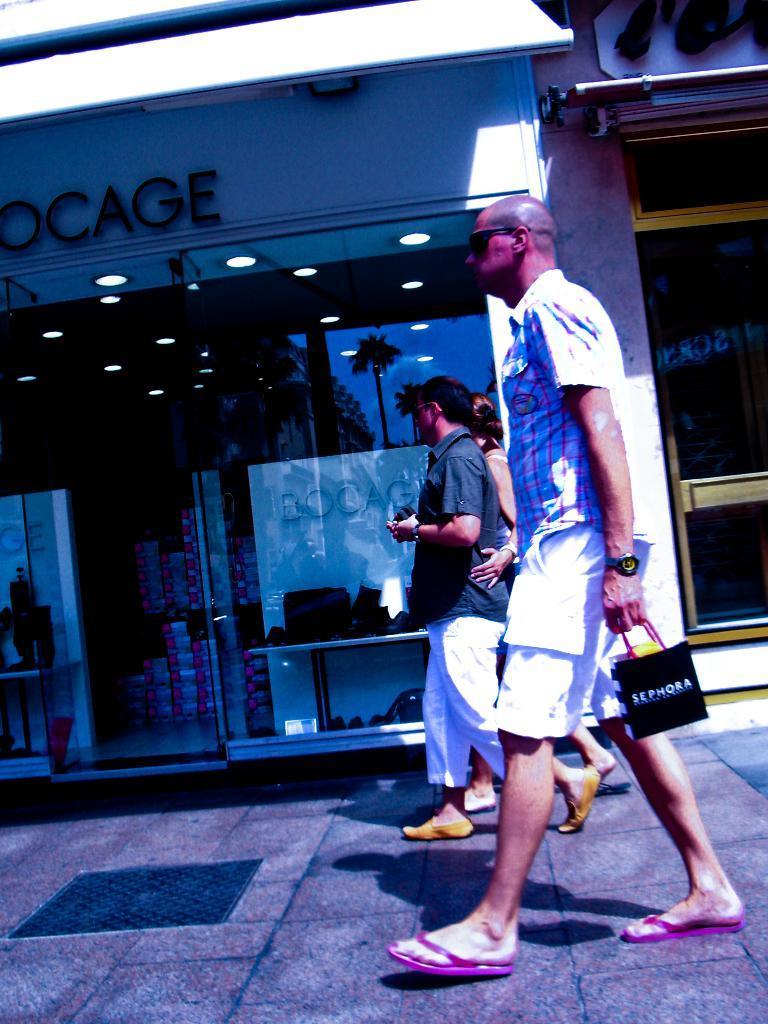Describe this image in one or two sentences. In this picture there are three persons walking on the footpath and there is a manhole on the footpath. At the back there are buildings and there is a text on the walls. There are objects behind the mirror and there are lights inside the room. There is a reflection of sky and there are reflections of trees on the mirror. 